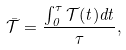Convert formula to latex. <formula><loc_0><loc_0><loc_500><loc_500>\bar { \mathcal { T } } = \frac { \int _ { 0 } ^ { \tau } \mathcal { T } ( t ) d t } { \tau } ,</formula> 